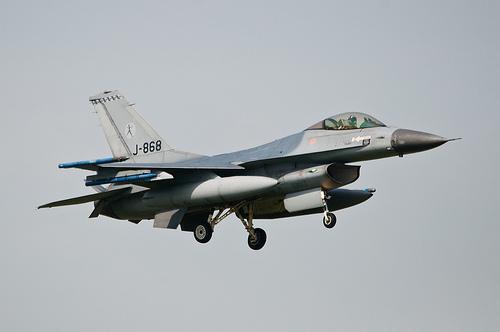How many jets are there?
Give a very brief answer. 1. 